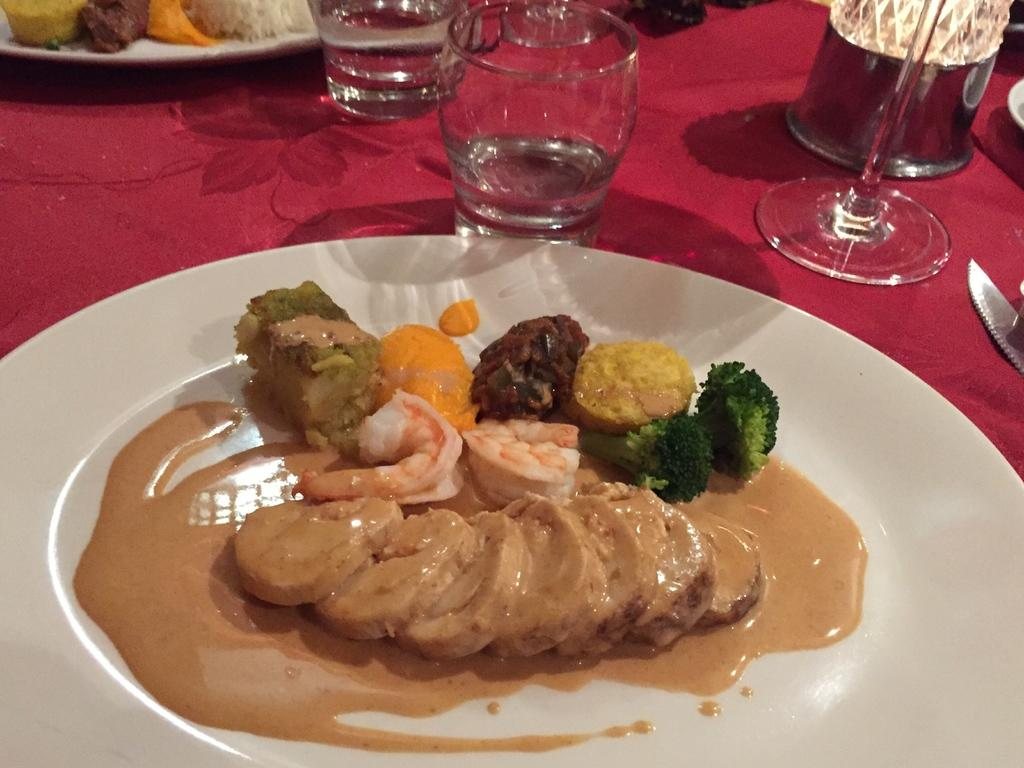What color is the cloth covering the table in the image? The table in the image is covered with a red cloth. What objects can be seen on the table besides the cloth? There are plates, glasses, a knife, a lamp, a drink, and different food items on the table. What might be used for cutting in the image? There is a knife on the table. What type of lighting is present on the table? There is a lamp on the table. What is the opinion of the lamp on the table in the image? The lamp does not have an opinion, as it is an inanimate object. 